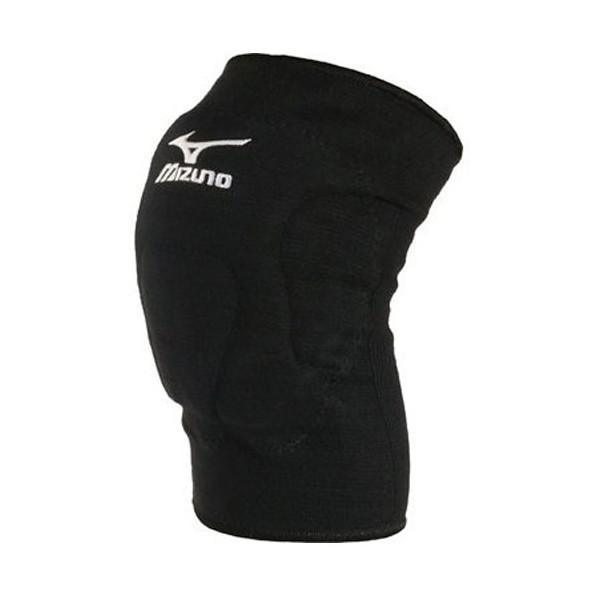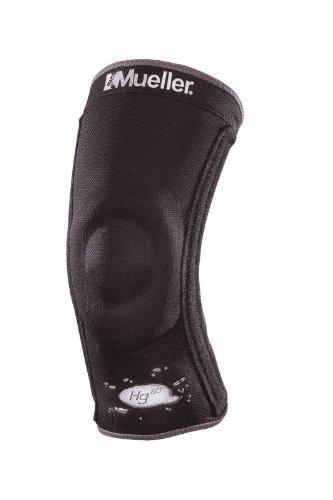The first image is the image on the left, the second image is the image on the right. Assess this claim about the two images: "There are three knee pads.". Correct or not? Answer yes or no. No. The first image is the image on the left, the second image is the image on the right. Assess this claim about the two images: "There are 3 knee braces in the images.". Correct or not? Answer yes or no. No. 